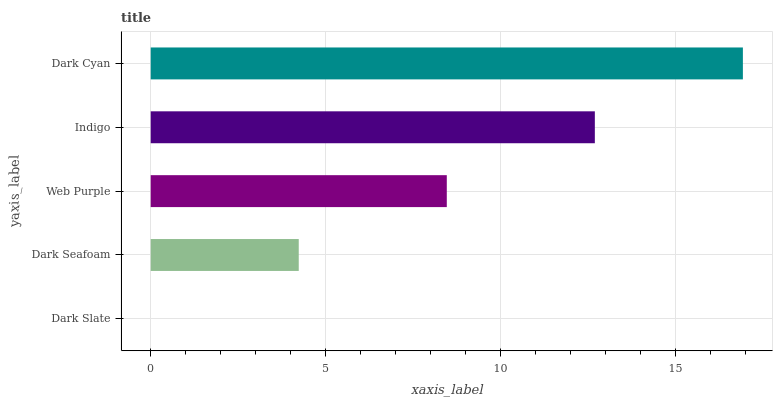Is Dark Slate the minimum?
Answer yes or no. Yes. Is Dark Cyan the maximum?
Answer yes or no. Yes. Is Dark Seafoam the minimum?
Answer yes or no. No. Is Dark Seafoam the maximum?
Answer yes or no. No. Is Dark Seafoam greater than Dark Slate?
Answer yes or no. Yes. Is Dark Slate less than Dark Seafoam?
Answer yes or no. Yes. Is Dark Slate greater than Dark Seafoam?
Answer yes or no. No. Is Dark Seafoam less than Dark Slate?
Answer yes or no. No. Is Web Purple the high median?
Answer yes or no. Yes. Is Web Purple the low median?
Answer yes or no. Yes. Is Dark Cyan the high median?
Answer yes or no. No. Is Dark Seafoam the low median?
Answer yes or no. No. 